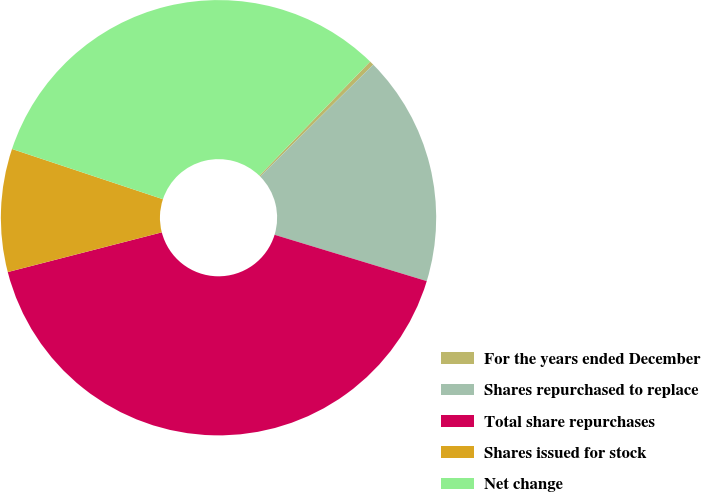Convert chart. <chart><loc_0><loc_0><loc_500><loc_500><pie_chart><fcel>For the years ended December<fcel>Shares repurchased to replace<fcel>Total share repurchases<fcel>Shares issued for stock<fcel>Net change<nl><fcel>0.32%<fcel>17.12%<fcel>41.28%<fcel>9.13%<fcel>32.15%<nl></chart> 